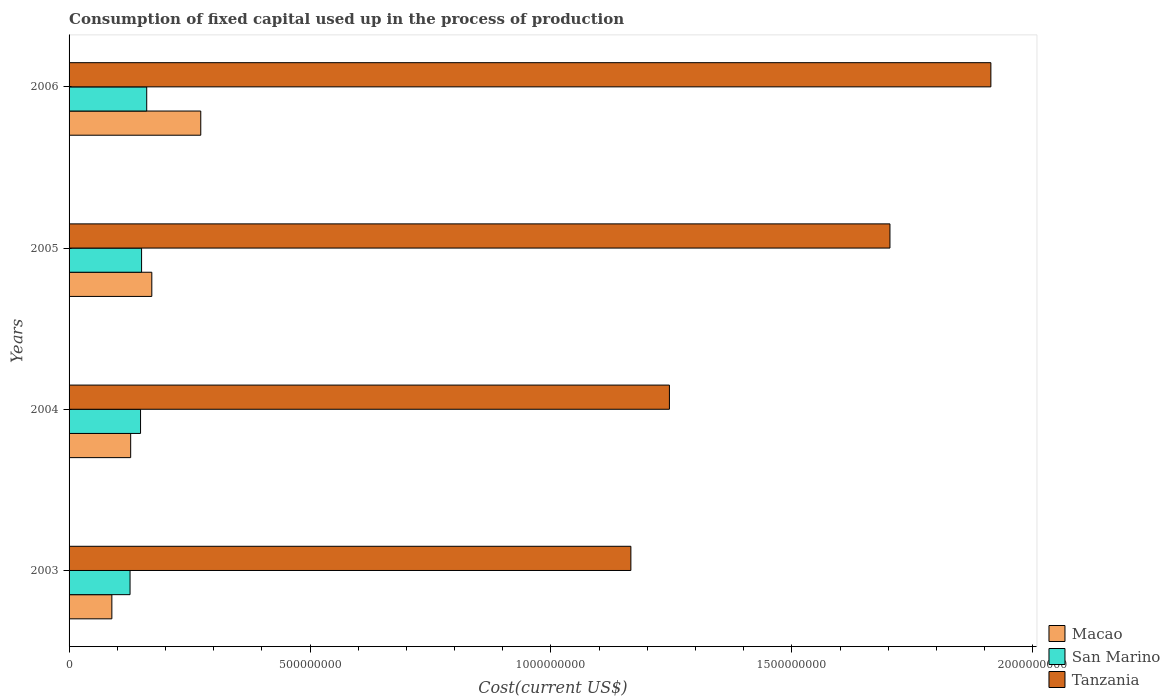How many different coloured bars are there?
Your answer should be very brief. 3. How many bars are there on the 2nd tick from the top?
Your answer should be compact. 3. How many bars are there on the 3rd tick from the bottom?
Ensure brevity in your answer.  3. In how many cases, is the number of bars for a given year not equal to the number of legend labels?
Ensure brevity in your answer.  0. What is the amount consumed in the process of production in San Marino in 2004?
Make the answer very short. 1.48e+08. Across all years, what is the maximum amount consumed in the process of production in Tanzania?
Ensure brevity in your answer.  1.91e+09. Across all years, what is the minimum amount consumed in the process of production in Tanzania?
Your response must be concise. 1.17e+09. In which year was the amount consumed in the process of production in San Marino minimum?
Offer a terse response. 2003. What is the total amount consumed in the process of production in Tanzania in the graph?
Ensure brevity in your answer.  6.03e+09. What is the difference between the amount consumed in the process of production in Macao in 2004 and that in 2006?
Your response must be concise. -1.45e+08. What is the difference between the amount consumed in the process of production in Macao in 2005 and the amount consumed in the process of production in Tanzania in 2003?
Your answer should be very brief. -9.94e+08. What is the average amount consumed in the process of production in Tanzania per year?
Provide a succinct answer. 1.51e+09. In the year 2003, what is the difference between the amount consumed in the process of production in Macao and amount consumed in the process of production in San Marino?
Your answer should be very brief. -3.78e+07. In how many years, is the amount consumed in the process of production in Tanzania greater than 1000000000 US$?
Keep it short and to the point. 4. What is the ratio of the amount consumed in the process of production in Tanzania in 2004 to that in 2006?
Give a very brief answer. 0.65. Is the amount consumed in the process of production in Tanzania in 2004 less than that in 2005?
Provide a short and direct response. Yes. What is the difference between the highest and the second highest amount consumed in the process of production in Tanzania?
Your answer should be very brief. 2.09e+08. What is the difference between the highest and the lowest amount consumed in the process of production in Tanzania?
Give a very brief answer. 7.47e+08. Is the sum of the amount consumed in the process of production in San Marino in 2003 and 2004 greater than the maximum amount consumed in the process of production in Tanzania across all years?
Make the answer very short. No. What does the 2nd bar from the top in 2006 represents?
Offer a very short reply. San Marino. What does the 2nd bar from the bottom in 2003 represents?
Your answer should be very brief. San Marino. How many years are there in the graph?
Your response must be concise. 4. What is the difference between two consecutive major ticks on the X-axis?
Offer a very short reply. 5.00e+08. Are the values on the major ticks of X-axis written in scientific E-notation?
Your answer should be very brief. No. How many legend labels are there?
Provide a short and direct response. 3. What is the title of the graph?
Your answer should be very brief. Consumption of fixed capital used up in the process of production. Does "Algeria" appear as one of the legend labels in the graph?
Your response must be concise. No. What is the label or title of the X-axis?
Make the answer very short. Cost(current US$). What is the Cost(current US$) of Macao in 2003?
Offer a very short reply. 8.88e+07. What is the Cost(current US$) in San Marino in 2003?
Offer a very short reply. 1.27e+08. What is the Cost(current US$) of Tanzania in 2003?
Your response must be concise. 1.17e+09. What is the Cost(current US$) of Macao in 2004?
Your answer should be compact. 1.28e+08. What is the Cost(current US$) of San Marino in 2004?
Your answer should be very brief. 1.48e+08. What is the Cost(current US$) of Tanzania in 2004?
Offer a very short reply. 1.25e+09. What is the Cost(current US$) of Macao in 2005?
Make the answer very short. 1.72e+08. What is the Cost(current US$) of San Marino in 2005?
Keep it short and to the point. 1.50e+08. What is the Cost(current US$) of Tanzania in 2005?
Your answer should be very brief. 1.70e+09. What is the Cost(current US$) in Macao in 2006?
Ensure brevity in your answer.  2.73e+08. What is the Cost(current US$) of San Marino in 2006?
Give a very brief answer. 1.61e+08. What is the Cost(current US$) of Tanzania in 2006?
Your answer should be very brief. 1.91e+09. Across all years, what is the maximum Cost(current US$) of Macao?
Your answer should be very brief. 2.73e+08. Across all years, what is the maximum Cost(current US$) in San Marino?
Provide a short and direct response. 1.61e+08. Across all years, what is the maximum Cost(current US$) of Tanzania?
Give a very brief answer. 1.91e+09. Across all years, what is the minimum Cost(current US$) in Macao?
Provide a succinct answer. 8.88e+07. Across all years, what is the minimum Cost(current US$) of San Marino?
Offer a terse response. 1.27e+08. Across all years, what is the minimum Cost(current US$) in Tanzania?
Offer a very short reply. 1.17e+09. What is the total Cost(current US$) in Macao in the graph?
Ensure brevity in your answer.  6.62e+08. What is the total Cost(current US$) of San Marino in the graph?
Your response must be concise. 5.86e+08. What is the total Cost(current US$) in Tanzania in the graph?
Make the answer very short. 6.03e+09. What is the difference between the Cost(current US$) of Macao in 2003 and that in 2004?
Provide a succinct answer. -3.91e+07. What is the difference between the Cost(current US$) in San Marino in 2003 and that in 2004?
Make the answer very short. -2.18e+07. What is the difference between the Cost(current US$) in Tanzania in 2003 and that in 2004?
Your answer should be compact. -8.00e+07. What is the difference between the Cost(current US$) of Macao in 2003 and that in 2005?
Offer a very short reply. -8.29e+07. What is the difference between the Cost(current US$) in San Marino in 2003 and that in 2005?
Your response must be concise. -2.39e+07. What is the difference between the Cost(current US$) of Tanzania in 2003 and that in 2005?
Provide a succinct answer. -5.38e+08. What is the difference between the Cost(current US$) of Macao in 2003 and that in 2006?
Your response must be concise. -1.85e+08. What is the difference between the Cost(current US$) of San Marino in 2003 and that in 2006?
Ensure brevity in your answer.  -3.46e+07. What is the difference between the Cost(current US$) of Tanzania in 2003 and that in 2006?
Your answer should be very brief. -7.47e+08. What is the difference between the Cost(current US$) of Macao in 2004 and that in 2005?
Your response must be concise. -4.39e+07. What is the difference between the Cost(current US$) in San Marino in 2004 and that in 2005?
Offer a very short reply. -2.13e+06. What is the difference between the Cost(current US$) of Tanzania in 2004 and that in 2005?
Ensure brevity in your answer.  -4.58e+08. What is the difference between the Cost(current US$) in Macao in 2004 and that in 2006?
Provide a succinct answer. -1.45e+08. What is the difference between the Cost(current US$) in San Marino in 2004 and that in 2006?
Give a very brief answer. -1.28e+07. What is the difference between the Cost(current US$) in Tanzania in 2004 and that in 2006?
Offer a very short reply. -6.67e+08. What is the difference between the Cost(current US$) in Macao in 2005 and that in 2006?
Provide a succinct answer. -1.02e+08. What is the difference between the Cost(current US$) of San Marino in 2005 and that in 2006?
Offer a very short reply. -1.07e+07. What is the difference between the Cost(current US$) of Tanzania in 2005 and that in 2006?
Provide a succinct answer. -2.09e+08. What is the difference between the Cost(current US$) of Macao in 2003 and the Cost(current US$) of San Marino in 2004?
Offer a very short reply. -5.95e+07. What is the difference between the Cost(current US$) in Macao in 2003 and the Cost(current US$) in Tanzania in 2004?
Give a very brief answer. -1.16e+09. What is the difference between the Cost(current US$) of San Marino in 2003 and the Cost(current US$) of Tanzania in 2004?
Offer a terse response. -1.12e+09. What is the difference between the Cost(current US$) in Macao in 2003 and the Cost(current US$) in San Marino in 2005?
Offer a terse response. -6.17e+07. What is the difference between the Cost(current US$) of Macao in 2003 and the Cost(current US$) of Tanzania in 2005?
Keep it short and to the point. -1.61e+09. What is the difference between the Cost(current US$) in San Marino in 2003 and the Cost(current US$) in Tanzania in 2005?
Give a very brief answer. -1.58e+09. What is the difference between the Cost(current US$) of Macao in 2003 and the Cost(current US$) of San Marino in 2006?
Your answer should be very brief. -7.24e+07. What is the difference between the Cost(current US$) of Macao in 2003 and the Cost(current US$) of Tanzania in 2006?
Offer a very short reply. -1.82e+09. What is the difference between the Cost(current US$) in San Marino in 2003 and the Cost(current US$) in Tanzania in 2006?
Provide a succinct answer. -1.79e+09. What is the difference between the Cost(current US$) of Macao in 2004 and the Cost(current US$) of San Marino in 2005?
Provide a short and direct response. -2.26e+07. What is the difference between the Cost(current US$) of Macao in 2004 and the Cost(current US$) of Tanzania in 2005?
Offer a terse response. -1.58e+09. What is the difference between the Cost(current US$) in San Marino in 2004 and the Cost(current US$) in Tanzania in 2005?
Keep it short and to the point. -1.56e+09. What is the difference between the Cost(current US$) of Macao in 2004 and the Cost(current US$) of San Marino in 2006?
Make the answer very short. -3.33e+07. What is the difference between the Cost(current US$) of Macao in 2004 and the Cost(current US$) of Tanzania in 2006?
Provide a short and direct response. -1.79e+09. What is the difference between the Cost(current US$) in San Marino in 2004 and the Cost(current US$) in Tanzania in 2006?
Your answer should be very brief. -1.76e+09. What is the difference between the Cost(current US$) in Macao in 2005 and the Cost(current US$) in San Marino in 2006?
Your response must be concise. 1.06e+07. What is the difference between the Cost(current US$) of Macao in 2005 and the Cost(current US$) of Tanzania in 2006?
Offer a very short reply. -1.74e+09. What is the difference between the Cost(current US$) of San Marino in 2005 and the Cost(current US$) of Tanzania in 2006?
Ensure brevity in your answer.  -1.76e+09. What is the average Cost(current US$) of Macao per year?
Ensure brevity in your answer.  1.65e+08. What is the average Cost(current US$) in San Marino per year?
Provide a succinct answer. 1.47e+08. What is the average Cost(current US$) of Tanzania per year?
Provide a short and direct response. 1.51e+09. In the year 2003, what is the difference between the Cost(current US$) of Macao and Cost(current US$) of San Marino?
Offer a very short reply. -3.78e+07. In the year 2003, what is the difference between the Cost(current US$) of Macao and Cost(current US$) of Tanzania?
Provide a succinct answer. -1.08e+09. In the year 2003, what is the difference between the Cost(current US$) of San Marino and Cost(current US$) of Tanzania?
Make the answer very short. -1.04e+09. In the year 2004, what is the difference between the Cost(current US$) in Macao and Cost(current US$) in San Marino?
Ensure brevity in your answer.  -2.05e+07. In the year 2004, what is the difference between the Cost(current US$) in Macao and Cost(current US$) in Tanzania?
Ensure brevity in your answer.  -1.12e+09. In the year 2004, what is the difference between the Cost(current US$) in San Marino and Cost(current US$) in Tanzania?
Provide a short and direct response. -1.10e+09. In the year 2005, what is the difference between the Cost(current US$) in Macao and Cost(current US$) in San Marino?
Provide a short and direct response. 2.13e+07. In the year 2005, what is the difference between the Cost(current US$) of Macao and Cost(current US$) of Tanzania?
Ensure brevity in your answer.  -1.53e+09. In the year 2005, what is the difference between the Cost(current US$) in San Marino and Cost(current US$) in Tanzania?
Make the answer very short. -1.55e+09. In the year 2006, what is the difference between the Cost(current US$) in Macao and Cost(current US$) in San Marino?
Your answer should be compact. 1.12e+08. In the year 2006, what is the difference between the Cost(current US$) in Macao and Cost(current US$) in Tanzania?
Your answer should be very brief. -1.64e+09. In the year 2006, what is the difference between the Cost(current US$) of San Marino and Cost(current US$) of Tanzania?
Your answer should be compact. -1.75e+09. What is the ratio of the Cost(current US$) of Macao in 2003 to that in 2004?
Ensure brevity in your answer.  0.69. What is the ratio of the Cost(current US$) of San Marino in 2003 to that in 2004?
Ensure brevity in your answer.  0.85. What is the ratio of the Cost(current US$) in Tanzania in 2003 to that in 2004?
Provide a succinct answer. 0.94. What is the ratio of the Cost(current US$) in Macao in 2003 to that in 2005?
Your response must be concise. 0.52. What is the ratio of the Cost(current US$) of San Marino in 2003 to that in 2005?
Give a very brief answer. 0.84. What is the ratio of the Cost(current US$) of Tanzania in 2003 to that in 2005?
Provide a short and direct response. 0.68. What is the ratio of the Cost(current US$) of Macao in 2003 to that in 2006?
Provide a succinct answer. 0.32. What is the ratio of the Cost(current US$) in San Marino in 2003 to that in 2006?
Provide a succinct answer. 0.79. What is the ratio of the Cost(current US$) of Tanzania in 2003 to that in 2006?
Ensure brevity in your answer.  0.61. What is the ratio of the Cost(current US$) in Macao in 2004 to that in 2005?
Your answer should be very brief. 0.74. What is the ratio of the Cost(current US$) of San Marino in 2004 to that in 2005?
Keep it short and to the point. 0.99. What is the ratio of the Cost(current US$) of Tanzania in 2004 to that in 2005?
Offer a very short reply. 0.73. What is the ratio of the Cost(current US$) in Macao in 2004 to that in 2006?
Your answer should be compact. 0.47. What is the ratio of the Cost(current US$) in San Marino in 2004 to that in 2006?
Your response must be concise. 0.92. What is the ratio of the Cost(current US$) in Tanzania in 2004 to that in 2006?
Your answer should be very brief. 0.65. What is the ratio of the Cost(current US$) in Macao in 2005 to that in 2006?
Your response must be concise. 0.63. What is the ratio of the Cost(current US$) in San Marino in 2005 to that in 2006?
Offer a terse response. 0.93. What is the ratio of the Cost(current US$) of Tanzania in 2005 to that in 2006?
Your response must be concise. 0.89. What is the difference between the highest and the second highest Cost(current US$) in Macao?
Your answer should be very brief. 1.02e+08. What is the difference between the highest and the second highest Cost(current US$) in San Marino?
Offer a very short reply. 1.07e+07. What is the difference between the highest and the second highest Cost(current US$) of Tanzania?
Offer a very short reply. 2.09e+08. What is the difference between the highest and the lowest Cost(current US$) in Macao?
Give a very brief answer. 1.85e+08. What is the difference between the highest and the lowest Cost(current US$) in San Marino?
Your response must be concise. 3.46e+07. What is the difference between the highest and the lowest Cost(current US$) of Tanzania?
Provide a short and direct response. 7.47e+08. 